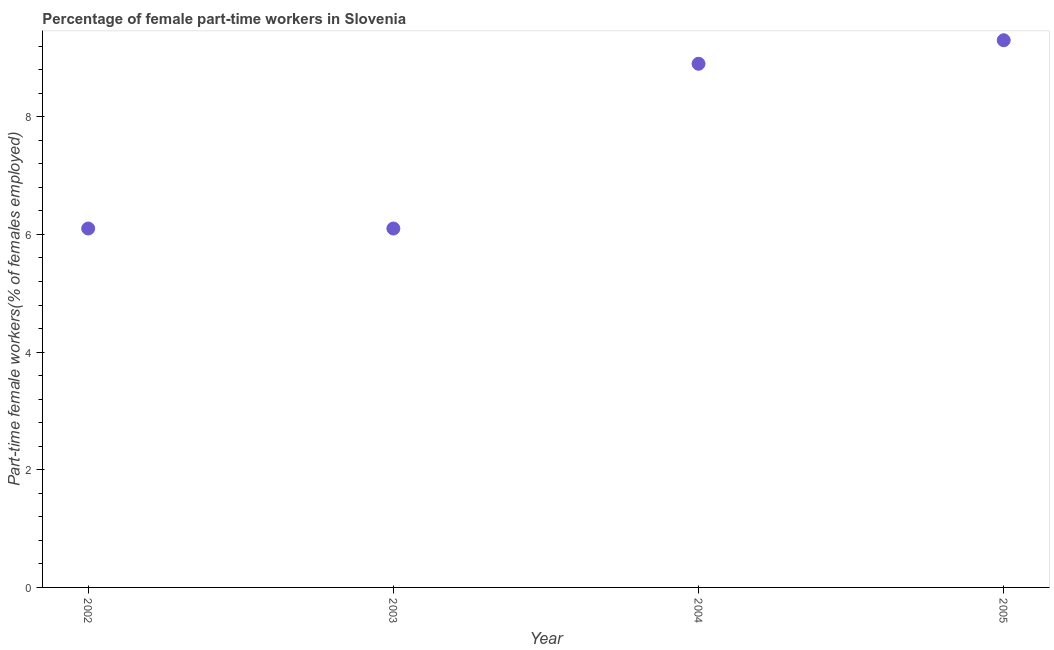What is the percentage of part-time female workers in 2005?
Offer a terse response. 9.3. Across all years, what is the maximum percentage of part-time female workers?
Your answer should be compact. 9.3. Across all years, what is the minimum percentage of part-time female workers?
Your response must be concise. 6.1. In which year was the percentage of part-time female workers maximum?
Your response must be concise. 2005. What is the sum of the percentage of part-time female workers?
Provide a succinct answer. 30.4. What is the difference between the percentage of part-time female workers in 2002 and 2004?
Your answer should be compact. -2.8. What is the average percentage of part-time female workers per year?
Give a very brief answer. 7.6. What is the median percentage of part-time female workers?
Your response must be concise. 7.5. Do a majority of the years between 2005 and 2003 (inclusive) have percentage of part-time female workers greater than 1.6 %?
Make the answer very short. No. What is the ratio of the percentage of part-time female workers in 2002 to that in 2004?
Your response must be concise. 0.69. Is the difference between the percentage of part-time female workers in 2002 and 2005 greater than the difference between any two years?
Your answer should be very brief. Yes. What is the difference between the highest and the second highest percentage of part-time female workers?
Your response must be concise. 0.4. Is the sum of the percentage of part-time female workers in 2002 and 2003 greater than the maximum percentage of part-time female workers across all years?
Ensure brevity in your answer.  Yes. What is the difference between the highest and the lowest percentage of part-time female workers?
Make the answer very short. 3.2. Does the percentage of part-time female workers monotonically increase over the years?
Keep it short and to the point. No. What is the difference between two consecutive major ticks on the Y-axis?
Your answer should be compact. 2. Does the graph contain any zero values?
Your answer should be compact. No. Does the graph contain grids?
Make the answer very short. No. What is the title of the graph?
Offer a terse response. Percentage of female part-time workers in Slovenia. What is the label or title of the X-axis?
Ensure brevity in your answer.  Year. What is the label or title of the Y-axis?
Keep it short and to the point. Part-time female workers(% of females employed). What is the Part-time female workers(% of females employed) in 2002?
Offer a very short reply. 6.1. What is the Part-time female workers(% of females employed) in 2003?
Give a very brief answer. 6.1. What is the Part-time female workers(% of females employed) in 2004?
Provide a succinct answer. 8.9. What is the Part-time female workers(% of females employed) in 2005?
Offer a very short reply. 9.3. What is the difference between the Part-time female workers(% of females employed) in 2002 and 2005?
Offer a very short reply. -3.2. What is the difference between the Part-time female workers(% of females employed) in 2003 and 2005?
Provide a succinct answer. -3.2. What is the ratio of the Part-time female workers(% of females employed) in 2002 to that in 2003?
Provide a succinct answer. 1. What is the ratio of the Part-time female workers(% of females employed) in 2002 to that in 2004?
Provide a succinct answer. 0.69. What is the ratio of the Part-time female workers(% of females employed) in 2002 to that in 2005?
Give a very brief answer. 0.66. What is the ratio of the Part-time female workers(% of females employed) in 2003 to that in 2004?
Keep it short and to the point. 0.69. What is the ratio of the Part-time female workers(% of females employed) in 2003 to that in 2005?
Provide a succinct answer. 0.66. 